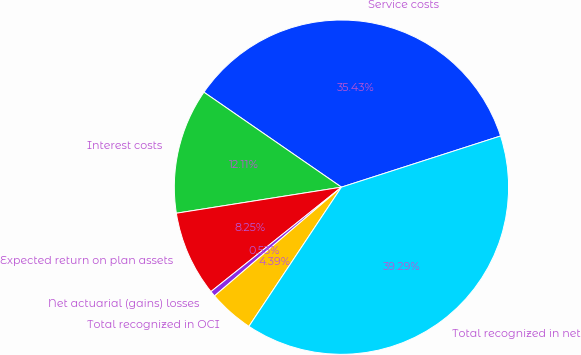Convert chart. <chart><loc_0><loc_0><loc_500><loc_500><pie_chart><fcel>Service costs<fcel>Interest costs<fcel>Expected return on plan assets<fcel>Net actuarial (gains) losses<fcel>Total recognized in OCI<fcel>Total recognized in net<nl><fcel>35.43%<fcel>12.11%<fcel>8.25%<fcel>0.53%<fcel>4.39%<fcel>39.29%<nl></chart> 